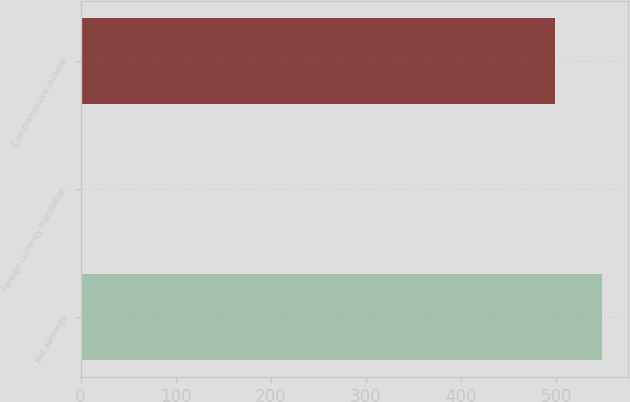Convert chart to OTSL. <chart><loc_0><loc_0><loc_500><loc_500><bar_chart><fcel>Net earnings<fcel>Foreign currency translation<fcel>Comprehensive income<nl><fcel>548.35<fcel>0.9<fcel>498.5<nl></chart> 